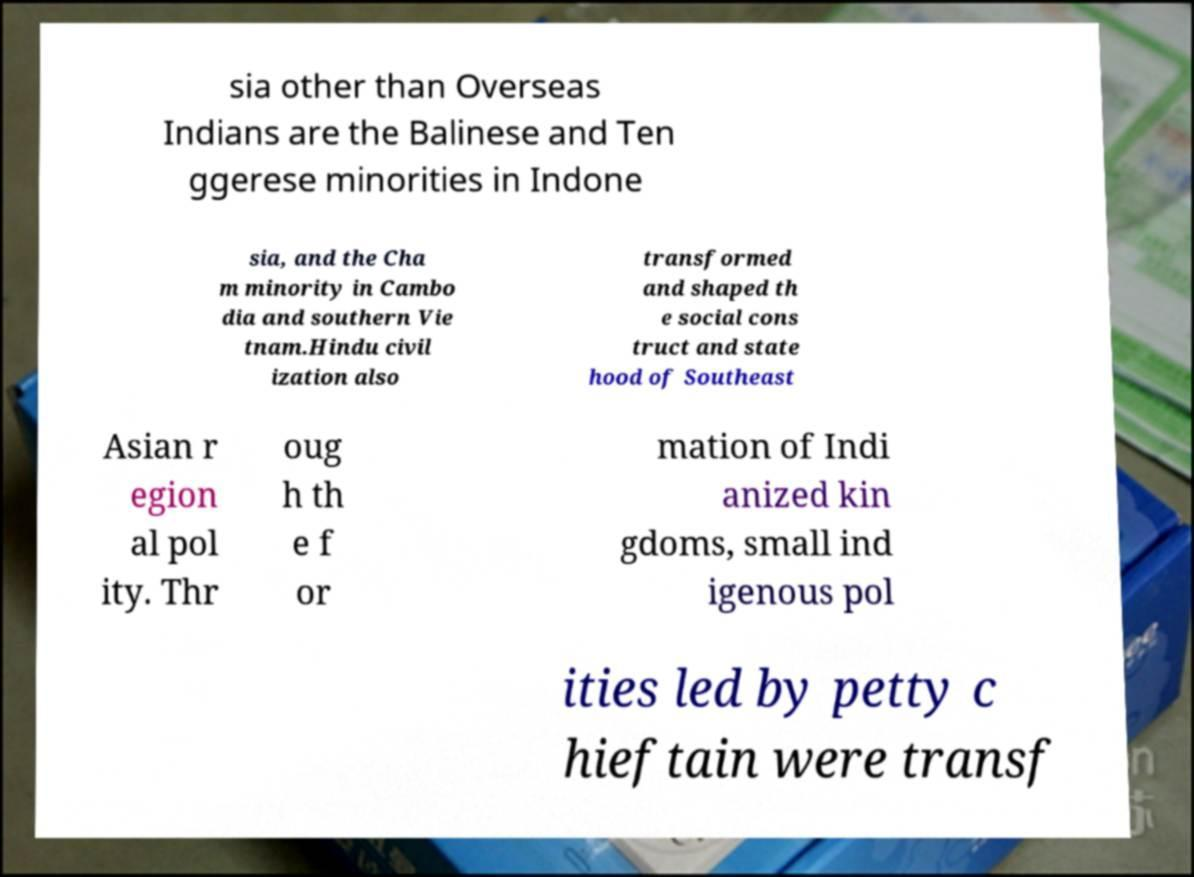What messages or text are displayed in this image? I need them in a readable, typed format. sia other than Overseas Indians are the Balinese and Ten ggerese minorities in Indone sia, and the Cha m minority in Cambo dia and southern Vie tnam.Hindu civil ization also transformed and shaped th e social cons truct and state hood of Southeast Asian r egion al pol ity. Thr oug h th e f or mation of Indi anized kin gdoms, small ind igenous pol ities led by petty c hieftain were transf 